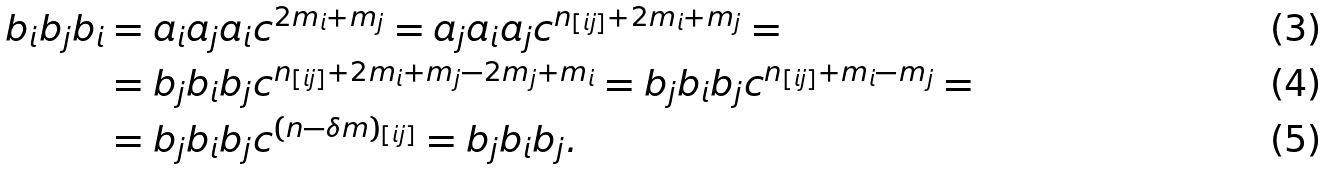Convert formula to latex. <formula><loc_0><loc_0><loc_500><loc_500>b _ { i } b _ { j } b _ { i } & = a _ { i } a _ { j } a _ { i } c ^ { 2 m _ { i } + m _ { j } } = a _ { j } a _ { i } a _ { j } c ^ { n _ { [ i j ] } + 2 m _ { i } + m _ { j } } = \\ & = b _ { j } b _ { i } b _ { j } c ^ { n _ { [ i j ] } + 2 m _ { i } + m _ { j } - 2 m _ { j } + m _ { i } } = b _ { j } b _ { i } b _ { j } c ^ { n _ { [ i j ] } + m _ { i } - m _ { j } } = \\ & = b _ { j } b _ { i } b _ { j } c ^ { ( n - \delta m ) _ { [ i j ] } } = b _ { j } b _ { i } b _ { j } .</formula> 